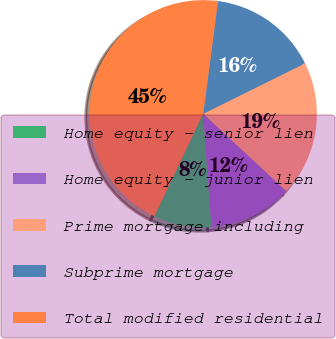Convert chart. <chart><loc_0><loc_0><loc_500><loc_500><pie_chart><fcel>Home equity - senior lien<fcel>Home equity - junior lien<fcel>Prime mortgage including<fcel>Subprime mortgage<fcel>Total modified residential<nl><fcel>8.23%<fcel>11.91%<fcel>19.26%<fcel>15.59%<fcel>45.01%<nl></chart> 